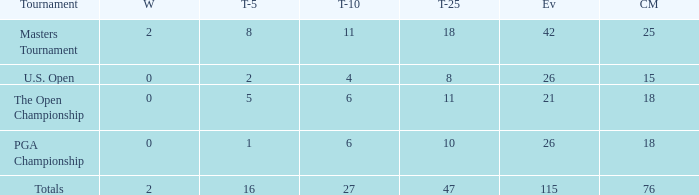How many average cuts made when 11 is the Top-10? 25.0. 